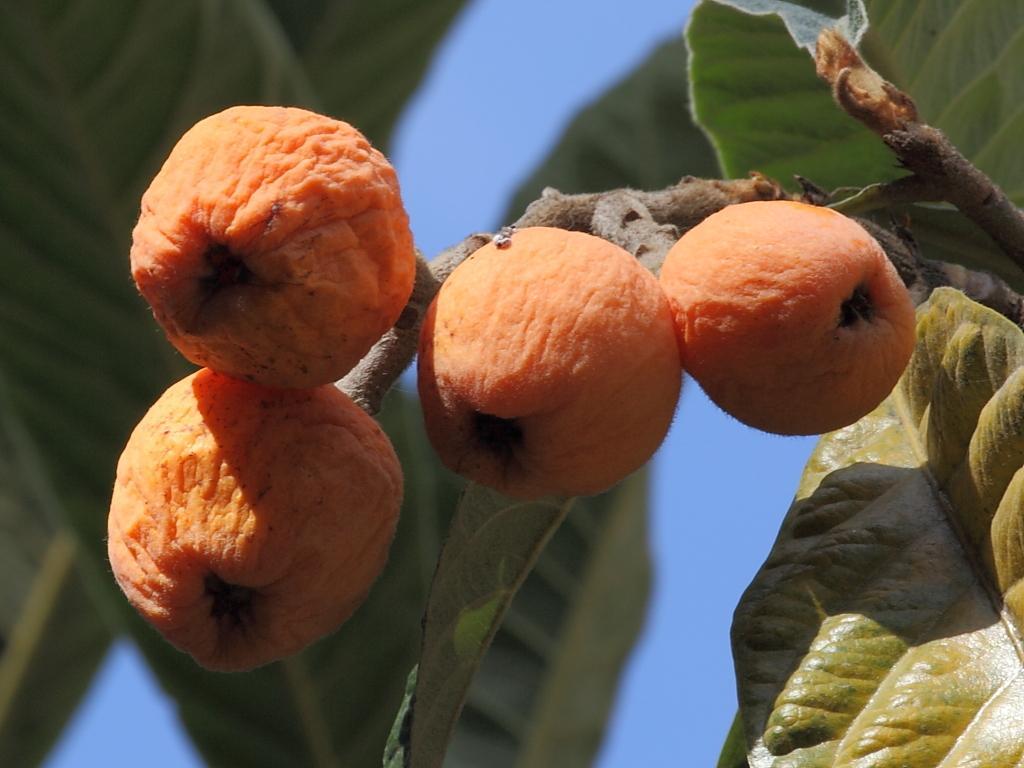Please provide a concise description of this image. In this image, we can see a stem with fruits and there are leaves. 